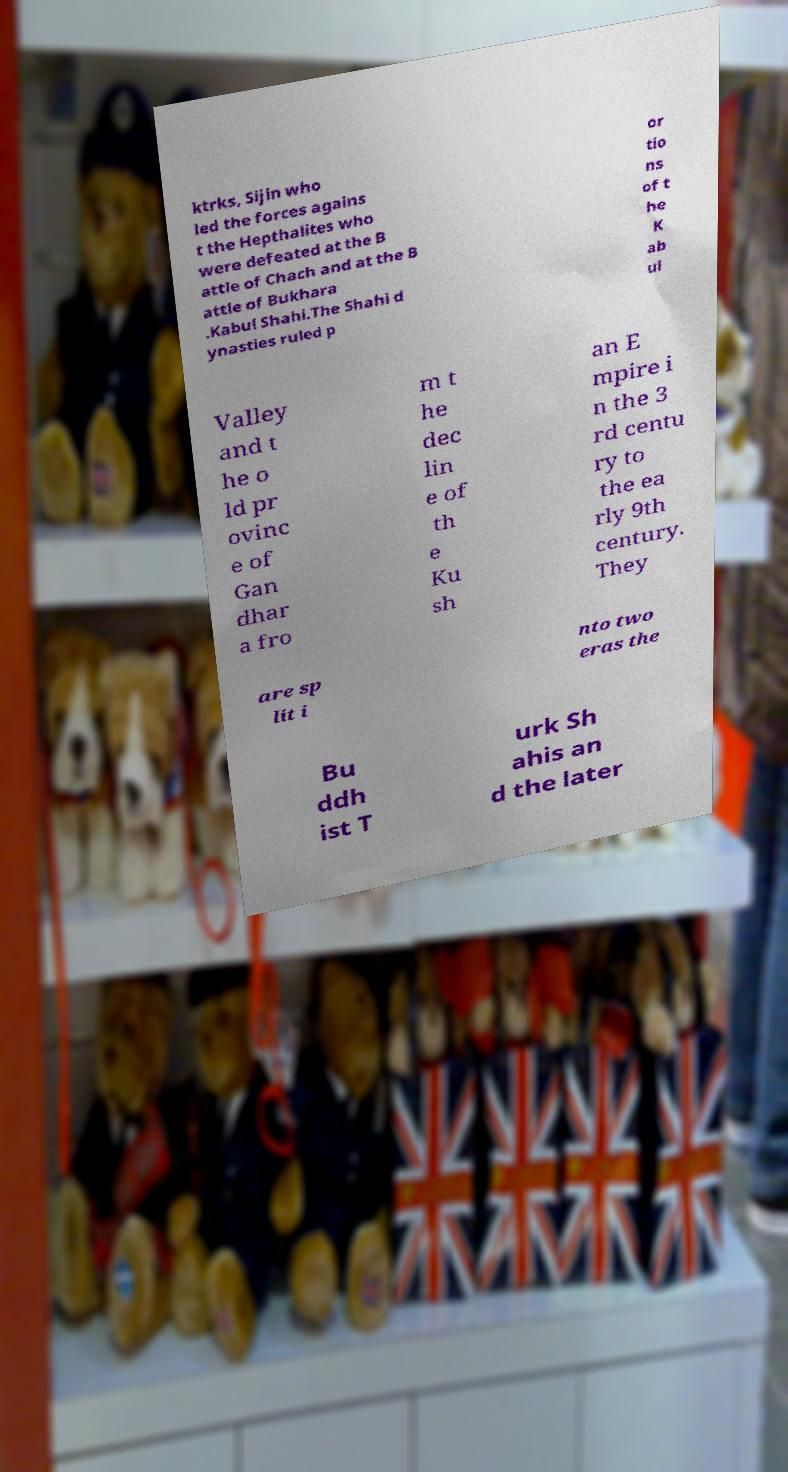There's text embedded in this image that I need extracted. Can you transcribe it verbatim? ktrks, Sijin who led the forces agains t the Hepthalites who were defeated at the B attle of Chach and at the B attle of Bukhara .Kabul Shahi.The Shahi d ynasties ruled p or tio ns of t he K ab ul Valley and t he o ld pr ovinc e of Gan dhar a fro m t he dec lin e of th e Ku sh an E mpire i n the 3 rd centu ry to the ea rly 9th century. They are sp lit i nto two eras the Bu ddh ist T urk Sh ahis an d the later 